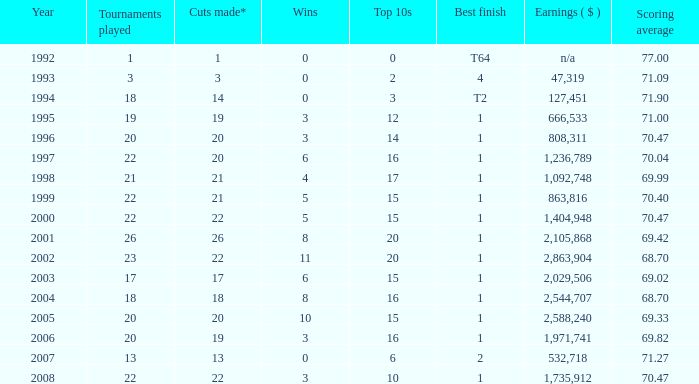Provide the scoring mean for years preceding 1998 with over 3 successes. 70.04. 